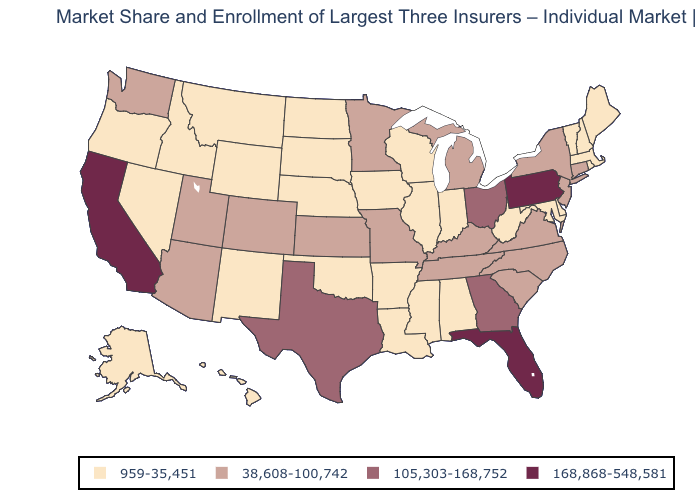Which states have the highest value in the USA?
Be succinct. California, Florida, Pennsylvania. Does Arkansas have a lower value than Connecticut?
Quick response, please. Yes. Does the first symbol in the legend represent the smallest category?
Write a very short answer. Yes. Which states have the highest value in the USA?
Write a very short answer. California, Florida, Pennsylvania. Does the first symbol in the legend represent the smallest category?
Write a very short answer. Yes. Among the states that border Wisconsin , does Michigan have the highest value?
Write a very short answer. Yes. Among the states that border West Virginia , which have the lowest value?
Short answer required. Maryland. What is the value of Mississippi?
Give a very brief answer. 959-35,451. Among the states that border South Dakota , which have the highest value?
Concise answer only. Minnesota. Does Virginia have the same value as Washington?
Be succinct. Yes. What is the lowest value in the USA?
Keep it brief. 959-35,451. Which states have the highest value in the USA?
Concise answer only. California, Florida, Pennsylvania. Which states have the lowest value in the USA?
Short answer required. Alabama, Alaska, Arkansas, Delaware, Hawaii, Idaho, Illinois, Indiana, Iowa, Louisiana, Maine, Maryland, Massachusetts, Mississippi, Montana, Nebraska, Nevada, New Hampshire, New Mexico, North Dakota, Oklahoma, Oregon, Rhode Island, South Dakota, Vermont, West Virginia, Wisconsin, Wyoming. Which states have the highest value in the USA?
Give a very brief answer. California, Florida, Pennsylvania. What is the value of Alaska?
Short answer required. 959-35,451. 